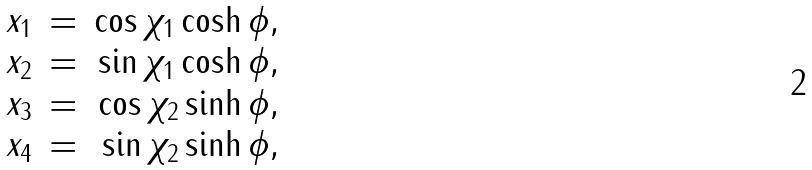<formula> <loc_0><loc_0><loc_500><loc_500>\begin{array} { c c r } x _ { 1 } & = & \cos \chi _ { 1 } \cosh \phi , \\ x _ { 2 } & = & \sin \chi _ { 1 } \cosh \phi , \\ x _ { 3 } & = & \cos \chi _ { 2 } \sinh \phi , \\ x _ { 4 } & = & \sin \chi _ { 2 } \sinh \phi , \end{array}</formula> 